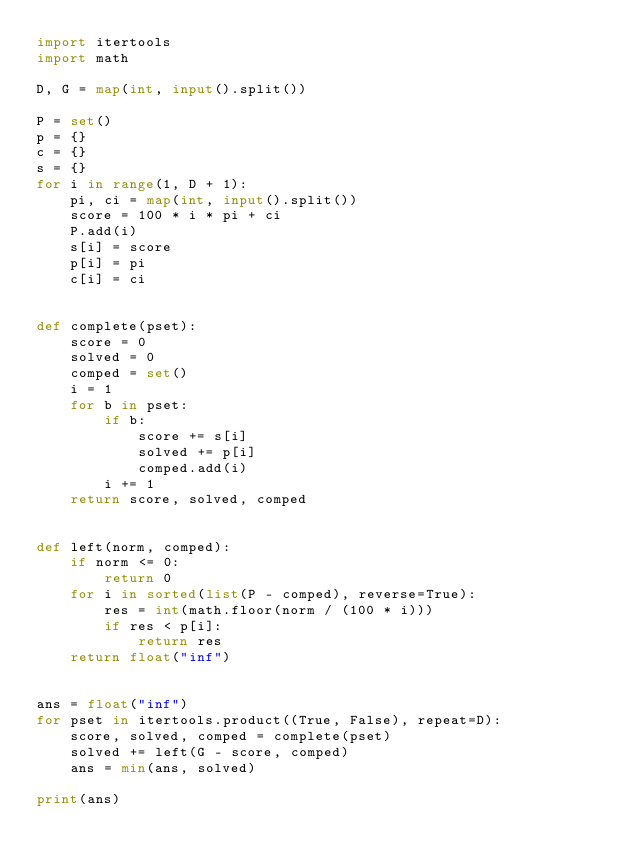Convert code to text. <code><loc_0><loc_0><loc_500><loc_500><_Python_>import itertools
import math

D, G = map(int, input().split())

P = set()
p = {}
c = {}
s = {}
for i in range(1, D + 1):
    pi, ci = map(int, input().split())
    score = 100 * i * pi + ci
    P.add(i)
    s[i] = score
    p[i] = pi
    c[i] = ci


def complete(pset):
    score = 0
    solved = 0
    comped = set()
    i = 1
    for b in pset:
        if b:
            score += s[i]
            solved += p[i]
            comped.add(i)
        i += 1
    return score, solved, comped


def left(norm, comped):
    if norm <= 0:
        return 0
    for i in sorted(list(P - comped), reverse=True):
        res = int(math.floor(norm / (100 * i)))
        if res < p[i]:
            return res
    return float("inf")


ans = float("inf")
for pset in itertools.product((True, False), repeat=D):
    score, solved, comped = complete(pset)
    solved += left(G - score, comped)
    ans = min(ans, solved)

print(ans)
</code> 